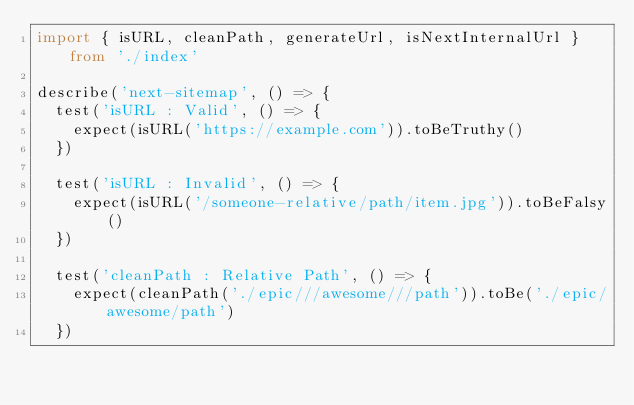<code> <loc_0><loc_0><loc_500><loc_500><_TypeScript_>import { isURL, cleanPath, generateUrl, isNextInternalUrl } from './index'

describe('next-sitemap', () => {
  test('isURL : Valid', () => {
    expect(isURL('https://example.com')).toBeTruthy()
  })

  test('isURL : Invalid', () => {
    expect(isURL('/someone-relative/path/item.jpg')).toBeFalsy()
  })

  test('cleanPath : Relative Path', () => {
    expect(cleanPath('./epic///awesome///path')).toBe('./epic/awesome/path')
  })
</code> 